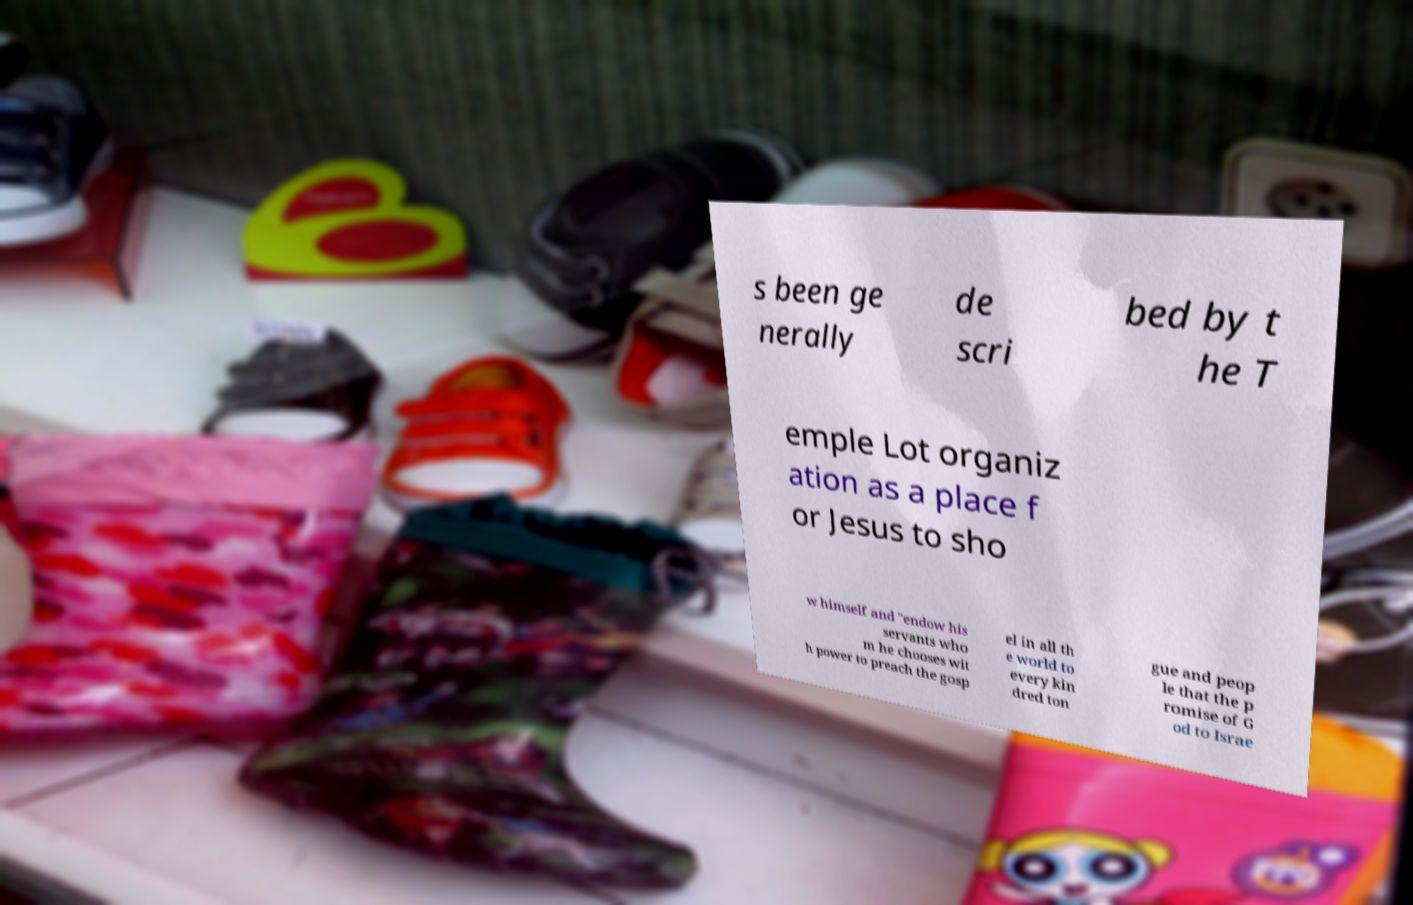Could you assist in decoding the text presented in this image and type it out clearly? s been ge nerally de scri bed by t he T emple Lot organiz ation as a place f or Jesus to sho w himself and "endow his servants who m he chooses wit h power to preach the gosp el in all th e world to every kin dred ton gue and peop le that the p romise of G od to Israe 